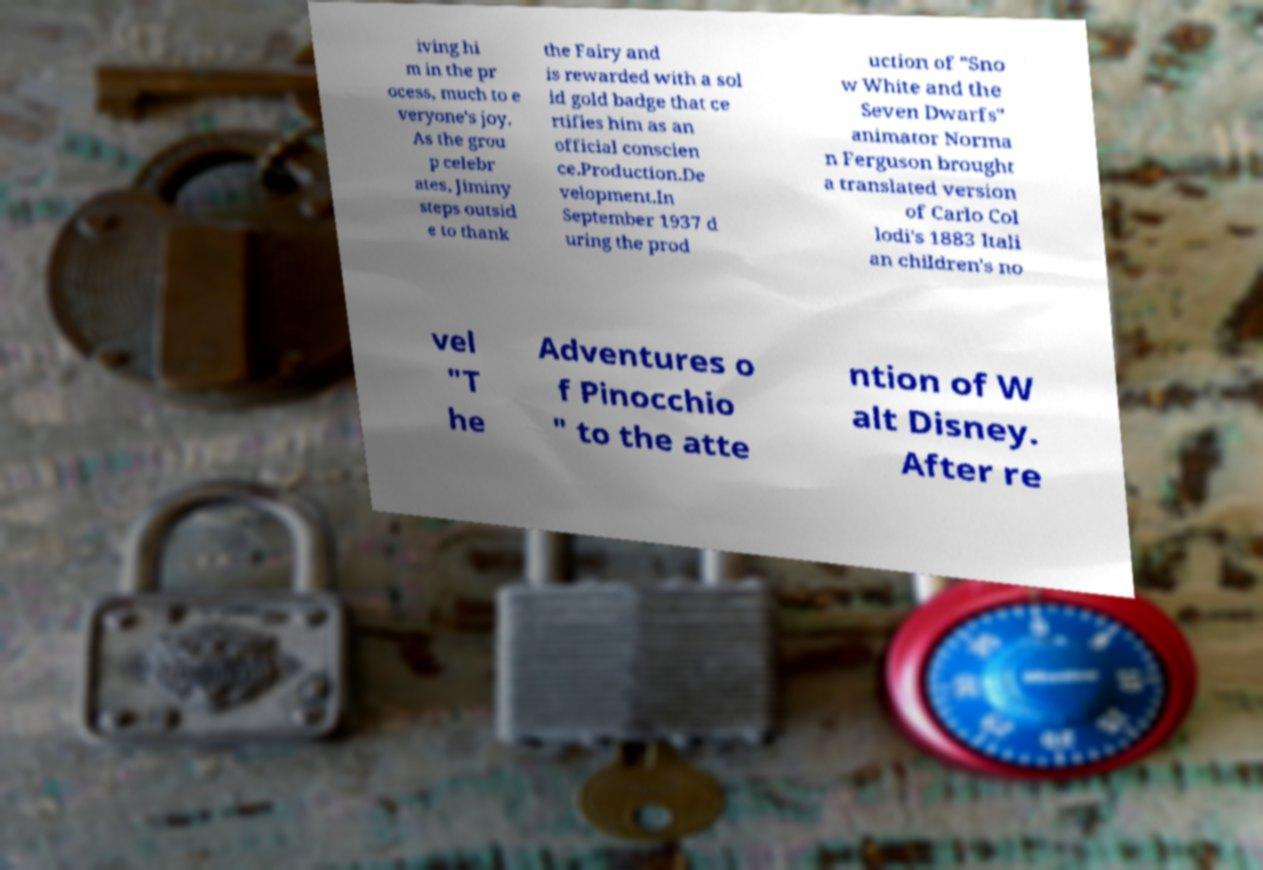Could you extract and type out the text from this image? iving hi m in the pr ocess, much to e veryone's joy. As the grou p celebr ates, Jiminy steps outsid e to thank the Fairy and is rewarded with a sol id gold badge that ce rtifies him as an official conscien ce.Production.De velopment.In September 1937 d uring the prod uction of "Sno w White and the Seven Dwarfs" animator Norma n Ferguson brought a translated version of Carlo Col lodi's 1883 Itali an children's no vel "T he Adventures o f Pinocchio " to the atte ntion of W alt Disney. After re 